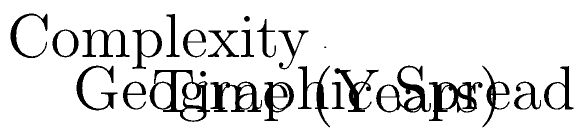In the 3D coordinate system depicting the historical development of writing systems, which writing system shows the highest rate of increase in geographic spread over time? To determine which writing system shows the highest rate of increase in geographic spread over time, we need to analyze the slopes of each line along the "Geographic Spread" axis:

1. Cuneiform (blue line):
   - Start: (0, 0)
   - End: (3000, 4)
   - Rate of change: (4 - 0) / (3000 - 0) = 4/3000 = 0.00133 units per year

2. Hieroglyphs (red line):
   - Start: (500, 1)
   - End: (3500, 3)
   - Rate of change: (3 - 1) / (3500 - 500) = 2/3000 = 0.00067 units per year

3. Alphabet (green line):
   - Start: (1000, 1)
   - End: (4000, 6)
   - Rate of change: (6 - 1) / (4000 - 1000) = 5/3000 = 0.00167 units per year

The alphabet system has the highest rate of increase in geographic spread over time at 0.00167 units per year.
Answer: Alphabet 